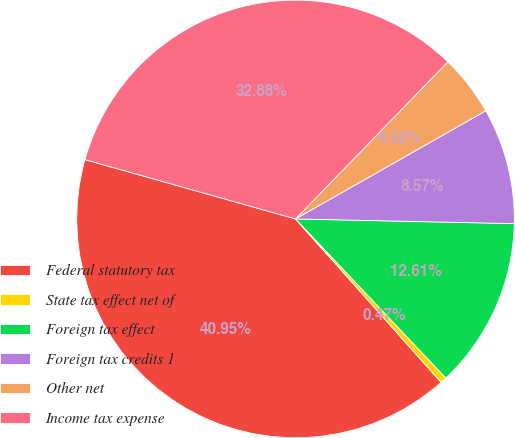Convert chart to OTSL. <chart><loc_0><loc_0><loc_500><loc_500><pie_chart><fcel>Federal statutory tax<fcel>State tax effect net of<fcel>Foreign tax effect<fcel>Foreign tax credits 1<fcel>Other net<fcel>Income tax expense<nl><fcel>40.95%<fcel>0.47%<fcel>12.61%<fcel>8.57%<fcel>4.52%<fcel>32.88%<nl></chart> 